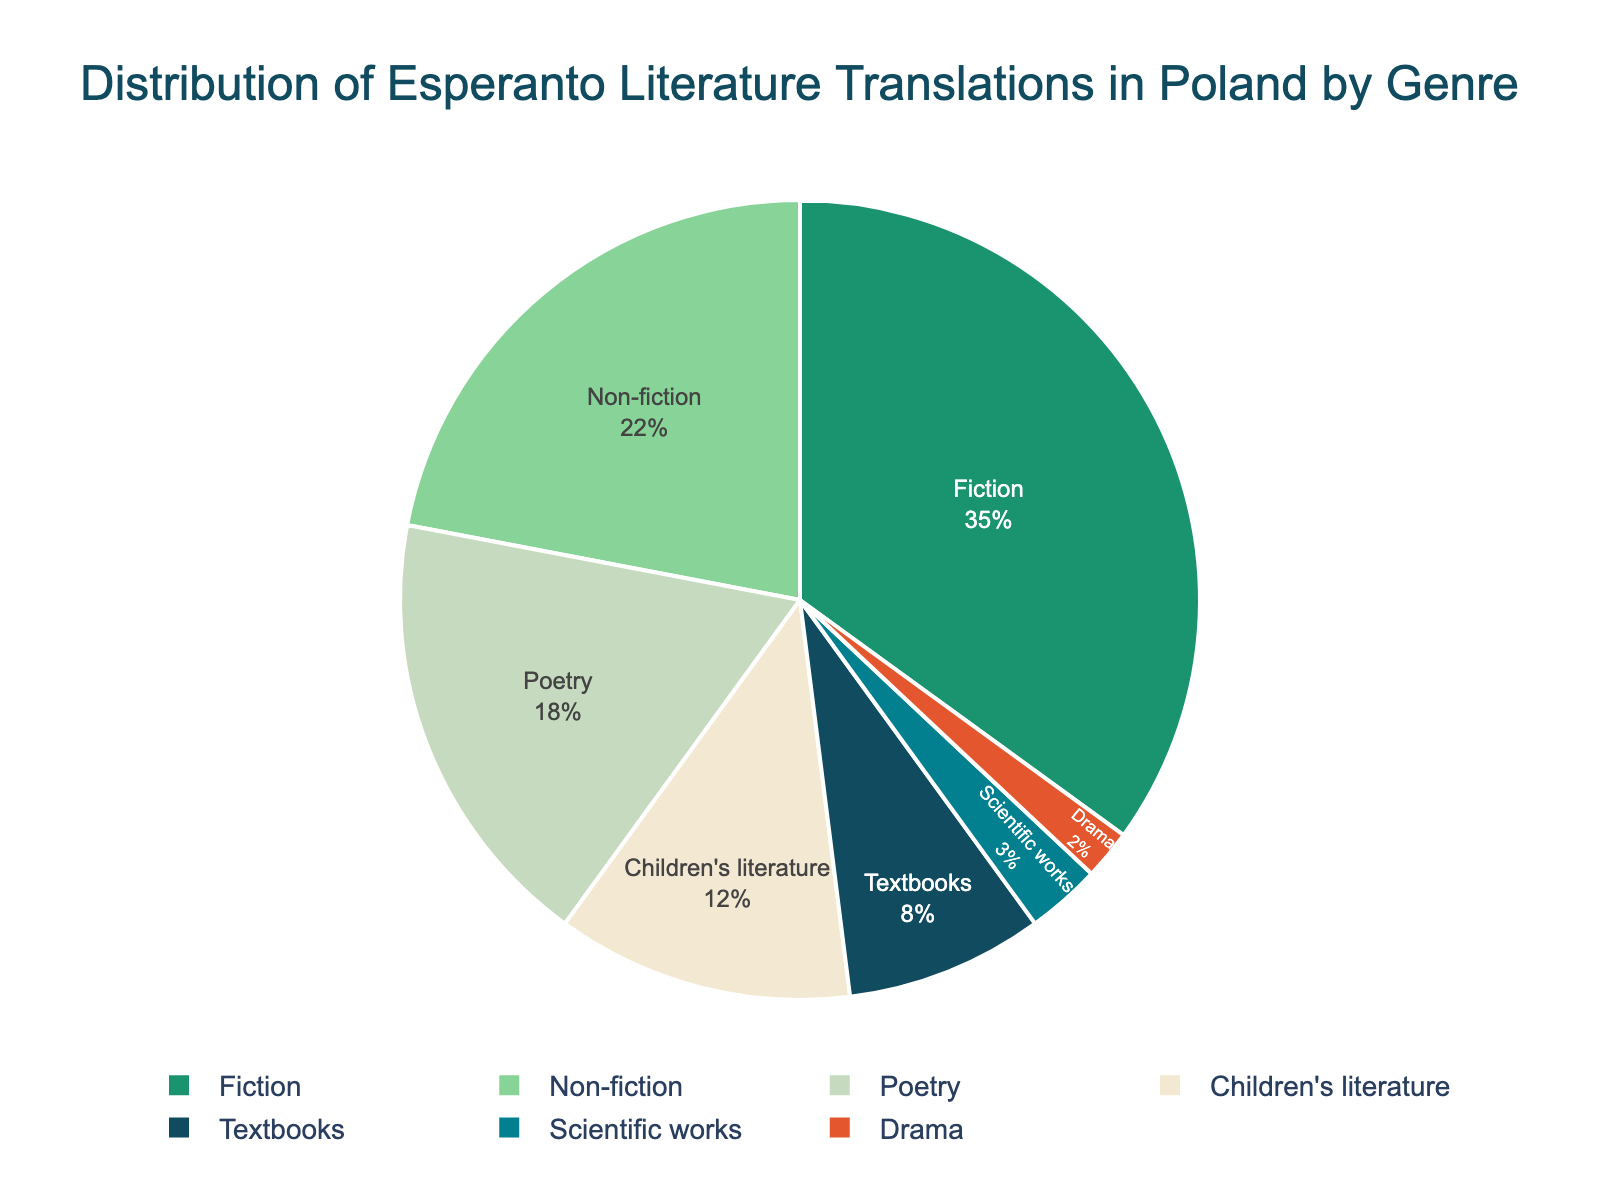What's the most common genre of Esperanto literature translations in Poland? The most common genre is the one with the highest percentage. In the figure, Fiction holds 35%, which is the largest.
Answer: Fiction Which genre has a smaller percentage, Drama or Textbooks? Compare the percentages of Drama and Textbooks. Drama has 2% while Textbooks have 8%, so Drama has a smaller percentage.
Answer: Drama What's the combined percentage of Children's literature and Poetry? Sum the percentages of Children's literature and Poetry: 12% + 18%.
Answer: 30% How much greater is the percentage of Fiction compared to Scientific works? Subtract the percentage of Scientific works from Fiction: 35% - 3%.
Answer: 32% If you combine Fiction and Non-fiction, what fraction of the total translations do they represent? Combine Fiction (35%) and Non-fiction (22%) to get a total of 57%. This is 57/100 of the total, which simplifies to 57%.
Answer: 57% What is the median value of the genre percentages? List the percentages in ascending order: 2%, 3%, 8%, 12%, 18%, 22%, 35%. The median is the middle value, which is 12%.
Answer: 12% Which genre has the closest percentage to one-third the Fiction's percentage? One-third of Fiction's percentage is 35% / 3, which is about 11.67%. Children's literature at 12% is closest to this value.
Answer: Children’s literature What percentage do genres other than Fiction represent? Subtract the percentage of Fiction from 100%: 100% - 35%.
Answer: 65% Is Non-fiction more or less than double the percentage of Drama? Double the percentage of Drama (2%) is 4%. Non-fiction is 22%, which is more than double Drama's percentage.
Answer: More How much less is the percentage of Poetry compared to the sum of Textbooks and Scientific works? Sum the percentages of Textbooks and Scientific works: 8% + 3% = 11%. Subtract this from Poetry's percentage: 18% - 11%.
Answer: 7% less 